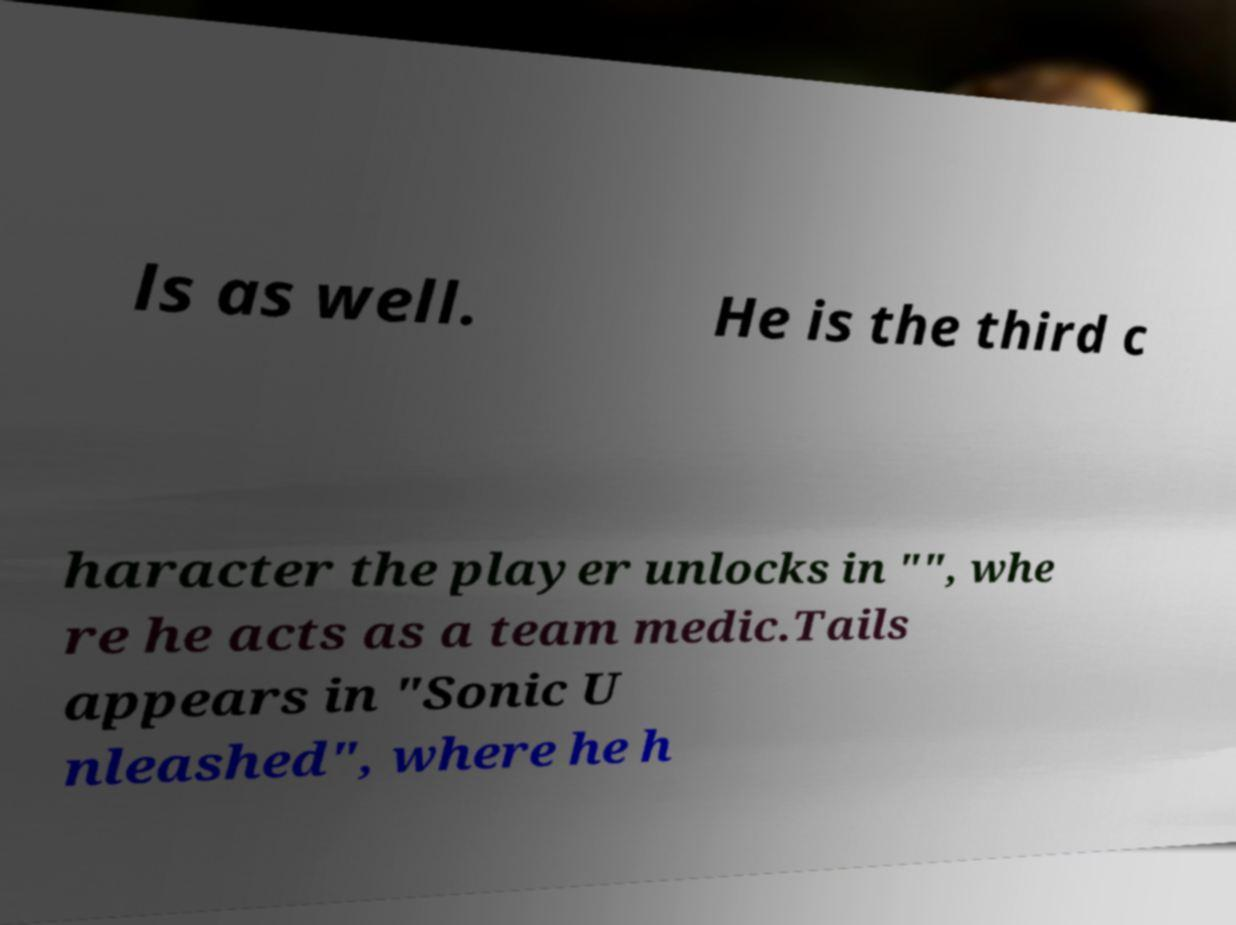I need the written content from this picture converted into text. Can you do that? ls as well. He is the third c haracter the player unlocks in "", whe re he acts as a team medic.Tails appears in "Sonic U nleashed", where he h 